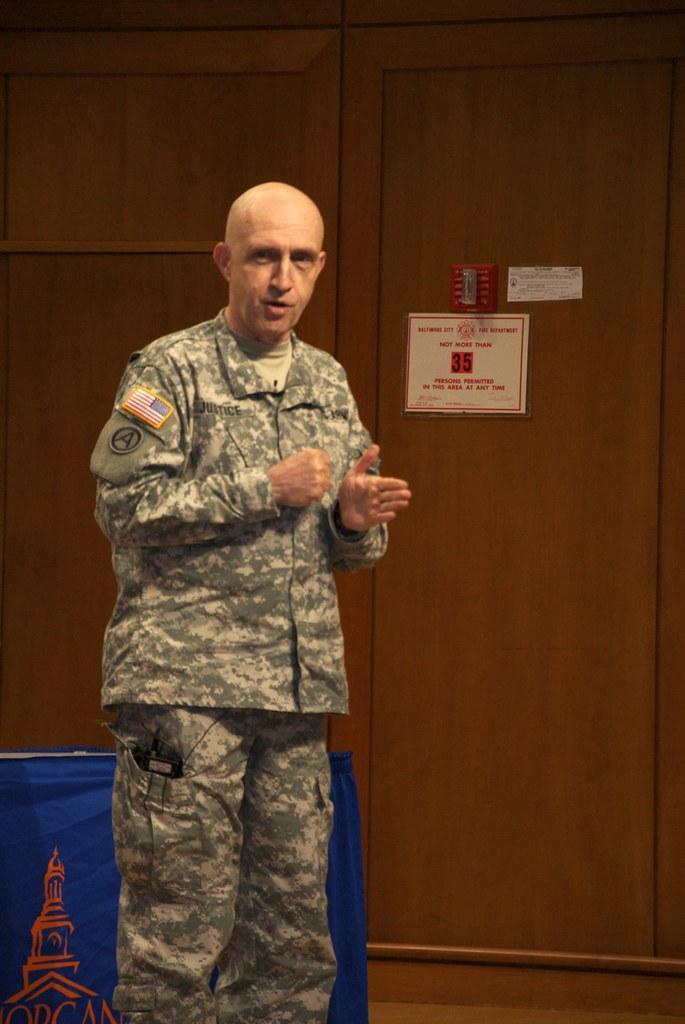Please provide a concise description of this image. In this image we can see a man. Behind the man we can see a table with a cloth. In the background, we can see a wooden wall. On the wall we can see the posters. 